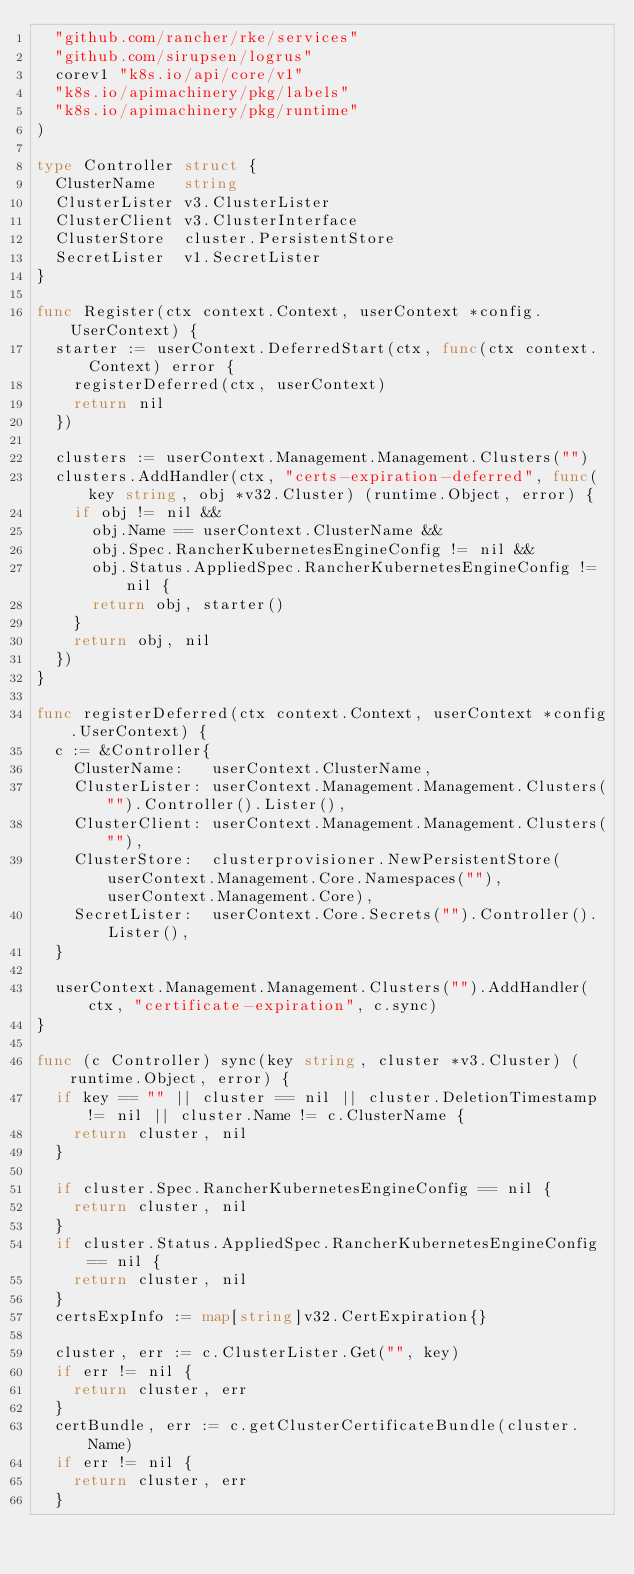Convert code to text. <code><loc_0><loc_0><loc_500><loc_500><_Go_>	"github.com/rancher/rke/services"
	"github.com/sirupsen/logrus"
	corev1 "k8s.io/api/core/v1"
	"k8s.io/apimachinery/pkg/labels"
	"k8s.io/apimachinery/pkg/runtime"
)

type Controller struct {
	ClusterName   string
	ClusterLister v3.ClusterLister
	ClusterClient v3.ClusterInterface
	ClusterStore  cluster.PersistentStore
	SecretLister  v1.SecretLister
}

func Register(ctx context.Context, userContext *config.UserContext) {
	starter := userContext.DeferredStart(ctx, func(ctx context.Context) error {
		registerDeferred(ctx, userContext)
		return nil
	})

	clusters := userContext.Management.Management.Clusters("")
	clusters.AddHandler(ctx, "certs-expiration-deferred", func(key string, obj *v32.Cluster) (runtime.Object, error) {
		if obj != nil &&
			obj.Name == userContext.ClusterName &&
			obj.Spec.RancherKubernetesEngineConfig != nil &&
			obj.Status.AppliedSpec.RancherKubernetesEngineConfig != nil {
			return obj, starter()
		}
		return obj, nil
	})
}

func registerDeferred(ctx context.Context, userContext *config.UserContext) {
	c := &Controller{
		ClusterName:   userContext.ClusterName,
		ClusterLister: userContext.Management.Management.Clusters("").Controller().Lister(),
		ClusterClient: userContext.Management.Management.Clusters(""),
		ClusterStore:  clusterprovisioner.NewPersistentStore(userContext.Management.Core.Namespaces(""), userContext.Management.Core),
		SecretLister:  userContext.Core.Secrets("").Controller().Lister(),
	}

	userContext.Management.Management.Clusters("").AddHandler(ctx, "certificate-expiration", c.sync)
}

func (c Controller) sync(key string, cluster *v3.Cluster) (runtime.Object, error) {
	if key == "" || cluster == nil || cluster.DeletionTimestamp != nil || cluster.Name != c.ClusterName {
		return cluster, nil
	}

	if cluster.Spec.RancherKubernetesEngineConfig == nil {
		return cluster, nil
	}
	if cluster.Status.AppliedSpec.RancherKubernetesEngineConfig == nil {
		return cluster, nil
	}
	certsExpInfo := map[string]v32.CertExpiration{}

	cluster, err := c.ClusterLister.Get("", key)
	if err != nil {
		return cluster, err
	}
	certBundle, err := c.getClusterCertificateBundle(cluster.Name)
	if err != nil {
		return cluster, err
	}</code> 